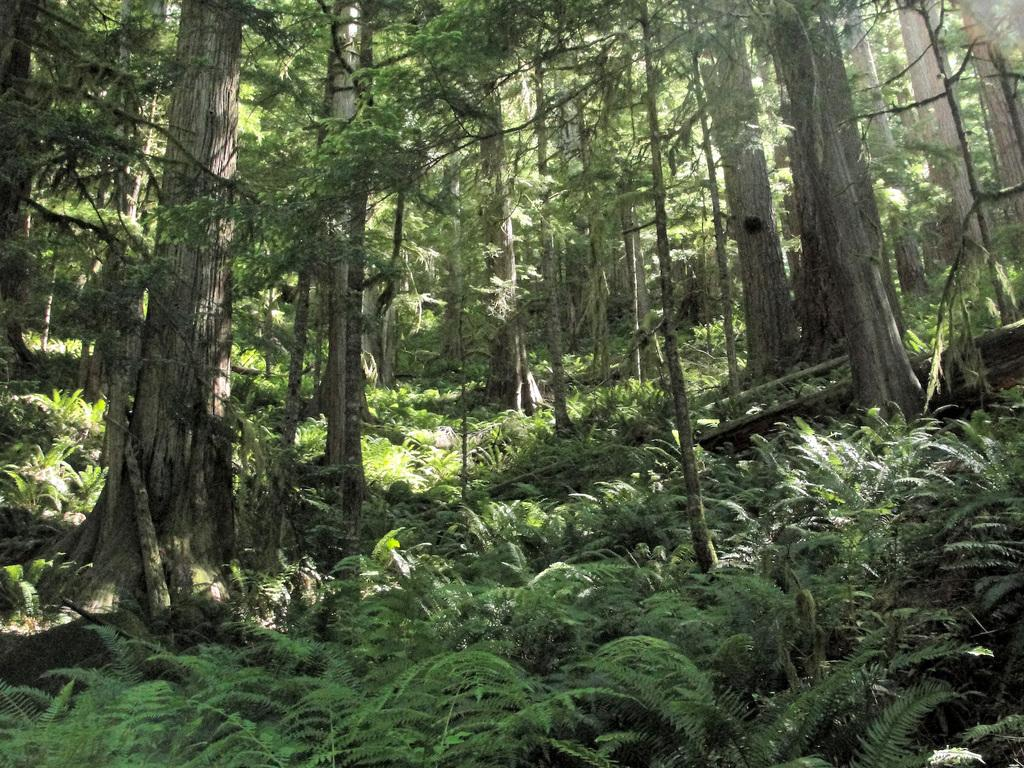What type of vegetation can be seen in the image? There are plants and trees in the image. Can you describe the specific types of plants or trees? The provided facts do not specify the types of plants or trees, so we cannot provide a detailed description. Where is the lamp located in the image? There is no lamp present in the image. What are the people in the image reading? There are no people or reading material present in the image. 